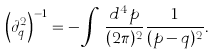Convert formula to latex. <formula><loc_0><loc_0><loc_500><loc_500>\left ( \partial _ { q } ^ { 2 } \right ) ^ { - 1 } = - \int \, \frac { d ^ { 4 } p } { ( 2 \pi ) ^ { 2 } } \frac { 1 } { ( p - q ) ^ { 2 } } .</formula> 